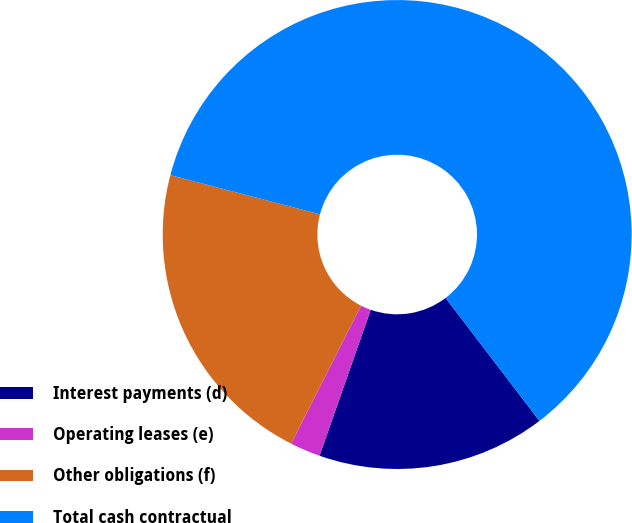<chart> <loc_0><loc_0><loc_500><loc_500><pie_chart><fcel>Interest payments (d)<fcel>Operating leases (e)<fcel>Other obligations (f)<fcel>Total cash contractual<nl><fcel>15.75%<fcel>2.1%<fcel>21.6%<fcel>60.55%<nl></chart> 